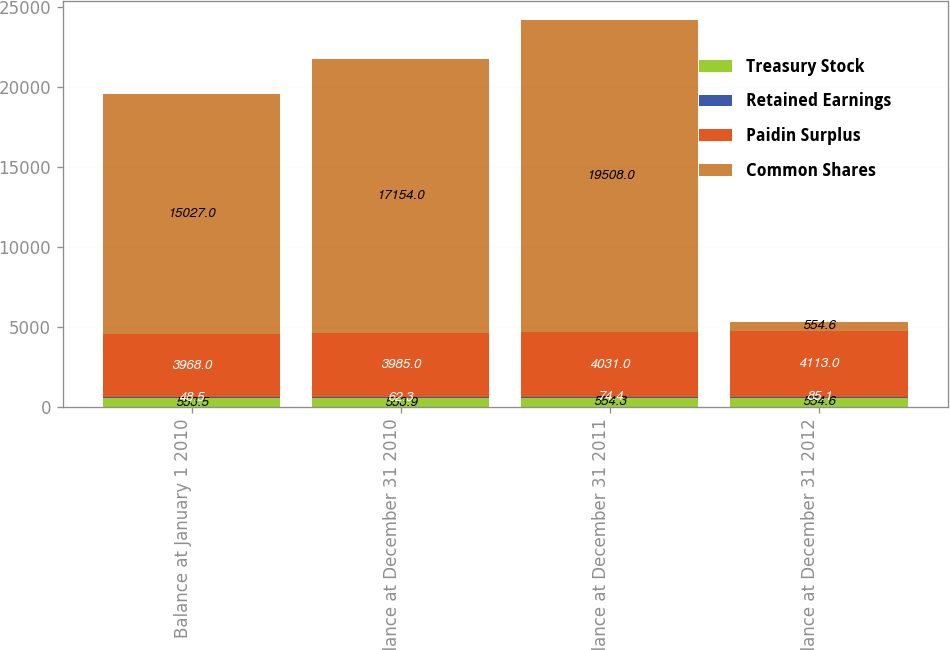<chart> <loc_0><loc_0><loc_500><loc_500><stacked_bar_chart><ecel><fcel>Balance at January 1 2010<fcel>Balance at December 31 2010<fcel>Balance at December 31 2011<fcel>Balance at December 31 2012<nl><fcel>Treasury Stock<fcel>553.5<fcel>553.9<fcel>554.3<fcel>554.6<nl><fcel>Retained Earnings<fcel>48.5<fcel>62.3<fcel>74.4<fcel>85.1<nl><fcel>Paidin Surplus<fcel>3968<fcel>3985<fcel>4031<fcel>4113<nl><fcel>Common Shares<fcel>15027<fcel>17154<fcel>19508<fcel>554.6<nl></chart> 